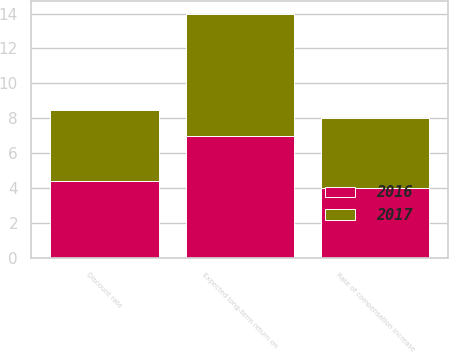Convert chart to OTSL. <chart><loc_0><loc_0><loc_500><loc_500><stacked_bar_chart><ecel><fcel>Discount rate<fcel>Expected long-term return on<fcel>Rate of compensation increase<nl><fcel>2017<fcel>4.1<fcel>7<fcel>4<nl><fcel>2016<fcel>4.4<fcel>7<fcel>4<nl></chart> 